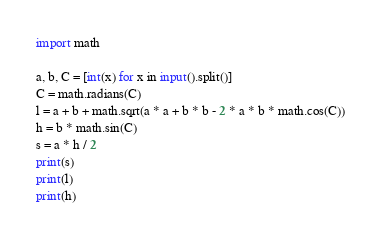Convert code to text. <code><loc_0><loc_0><loc_500><loc_500><_Python_>import math

a, b, C = [int(x) for x in input().split()]
C = math.radians(C)
l = a + b + math.sqrt(a * a + b * b - 2 * a * b * math.cos(C))
h = b * math.sin(C)
s = a * h / 2
print(s)
print(l)
print(h)</code> 